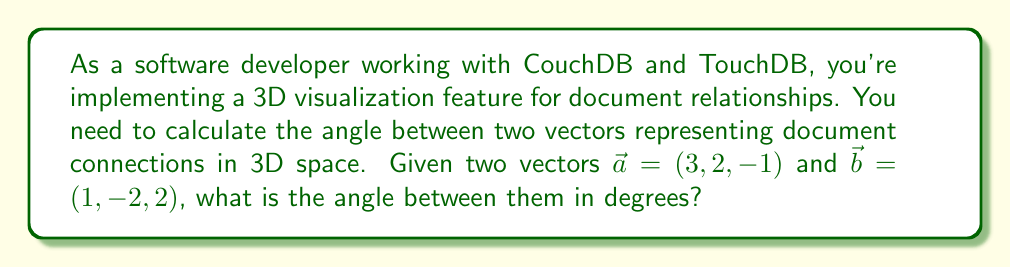Show me your answer to this math problem. To calculate the angle between two vectors in 3D space, we'll use the dot product formula and follow these steps:

1. Calculate the dot product of the vectors:
   $$\vec{a} \cdot \vec{b} = a_x b_x + a_y b_y + a_z b_z$$
   $$\vec{a} \cdot \vec{b} = (3)(1) + (2)(-2) + (-1)(2) = 3 - 4 - 2 = -3$$

2. Calculate the magnitudes of both vectors:
   $$|\vec{a}| = \sqrt{a_x^2 + a_y^2 + a_z^2} = \sqrt{3^2 + 2^2 + (-1)^2} = \sqrt{14}$$
   $$|\vec{b}| = \sqrt{b_x^2 + b_y^2 + b_z^2} = \sqrt{1^2 + (-2)^2 + 2^2} = \sqrt{9} = 3$$

3. Use the dot product formula to find the cosine of the angle:
   $$\cos \theta = \frac{\vec{a} \cdot \vec{b}}{|\vec{a}||\vec{b}|}$$
   $$\cos \theta = \frac{-3}{\sqrt{14} \cdot 3}$$

4. Take the inverse cosine (arccos) of both sides:
   $$\theta = \arccos\left(\frac{-3}{\sqrt{14} \cdot 3}\right)$$

5. Convert the angle from radians to degrees:
   $$\theta_{degrees} = \theta_{radians} \cdot \frac{180°}{\pi}$$

Calculating this:
$$\theta_{degrees} = \arccos\left(\frac{-3}{\sqrt{14} \cdot 3}\right) \cdot \frac{180°}{\pi} \approx 106.60°$$
Answer: The angle between the two vectors is approximately 106.60°. 